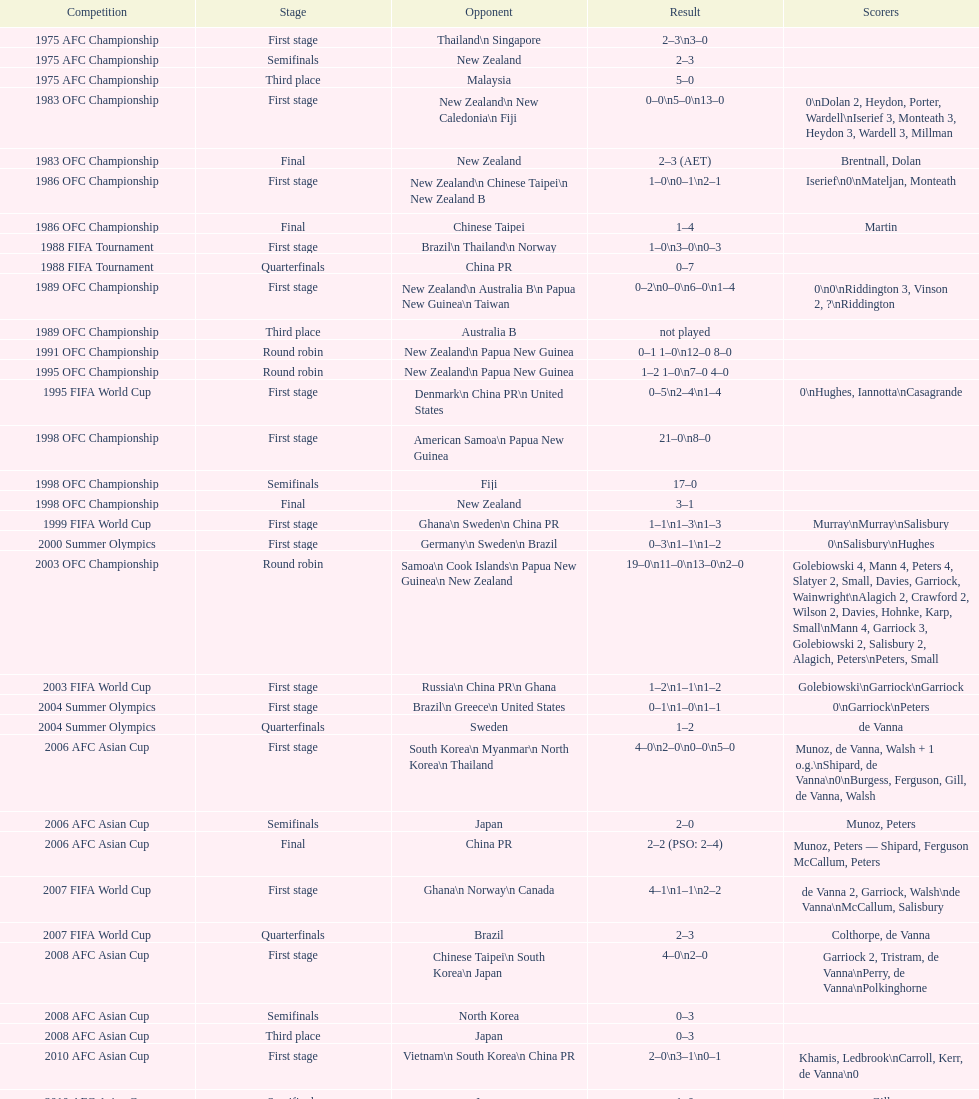What it the total number of countries in the first stage of the 2008 afc asian cup? 4. 